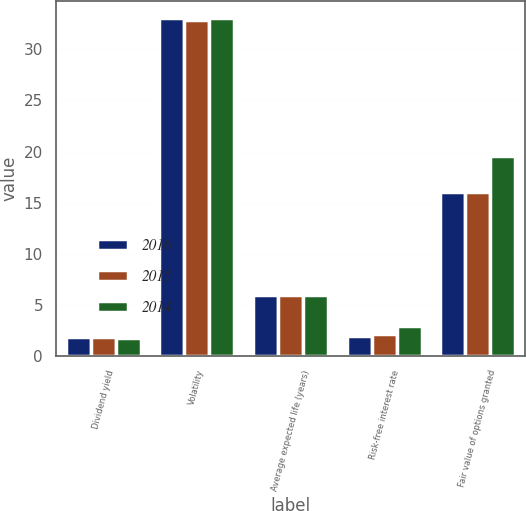Convert chart to OTSL. <chart><loc_0><loc_0><loc_500><loc_500><stacked_bar_chart><ecel><fcel>Dividend yield<fcel>Volatility<fcel>Average expected life (years)<fcel>Risk-free interest rate<fcel>Fair value of options granted<nl><fcel>2016<fcel>1.84<fcel>33.08<fcel>6<fcel>1.96<fcel>16.06<nl><fcel>2015<fcel>1.8<fcel>32.92<fcel>6<fcel>2.17<fcel>16.04<nl><fcel>2014<fcel>1.71<fcel>33.03<fcel>6<fcel>2.94<fcel>19.56<nl></chart> 